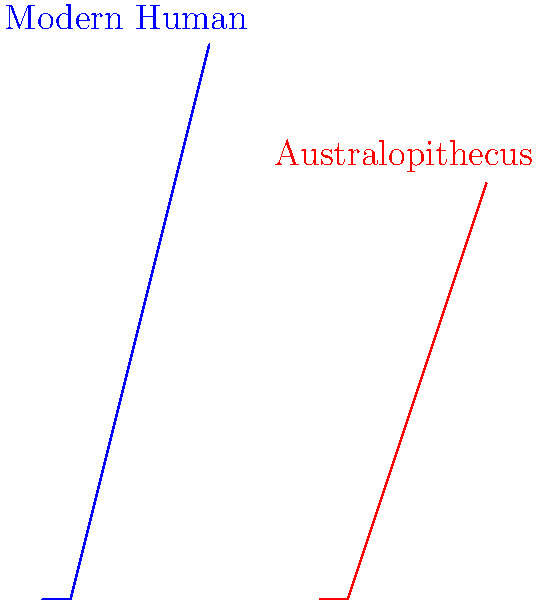As an aspiring archaeologist engaging in a role-play scenario, you've uncovered skeletal remains of an Australopithecus and are comparing it to modern human anatomy. Based on the silhouettes in the image, which key biomechanical difference would you identify that significantly impacts locomotion, and how would you explain its evolutionary significance? To answer this question, let's analyze the silhouettes step-by-step:

1. Observe the overall body proportions:
   - The modern human (blue) is taller and more upright.
   - The Australopithecus (red) is shorter and has a more bent posture.

2. Focus on the lower body:
   - The modern human's legs are longer relative to body height.
   - The Australopithecus has shorter legs and a lower hip position.

3. Identify the key difference: The position and angle of the hips.
   - Modern humans have higher, more outward-facing hip joints.
   - Australopithecus has lower, more inward-facing hip joints.

4. Biomechanical implications:
   - Higher, outward-facing hips in humans allow for efficient bipedal locomotion.
   - Lower, inward-facing hips in Australopithecus suggest a less efficient bipedal gait.

5. Evolutionary significance:
   - The change in hip structure represents a crucial adaptation for full bipedalism.
   - This adaptation allowed for more energy-efficient walking and running in later hominids.
   - It freed up the hands for tool use and carrying, potentially driving cognitive evolution.

6. Additional considerations:
   - The modern human's S-shaped spine (implied by the upright posture) also contributes to efficient bipedalism.
   - The Australopithecus' bent posture suggests it was in a transitional phase between arboreal and terrestrial locomotion.

The key biomechanical difference is the hip structure and position, which significantly impacted the efficiency of bipedal locomotion and played a crucial role in human evolution.
Answer: Hip structure and position: higher and outward-facing in humans, enabling efficient bipedalism and driving evolutionary changes. 